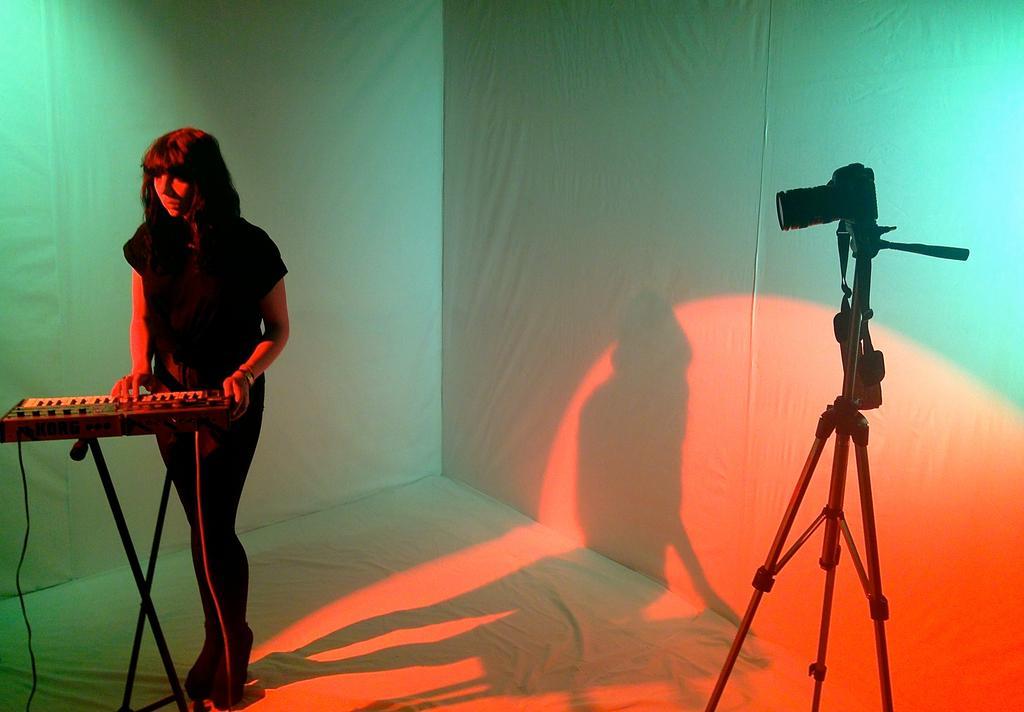Could you give a brief overview of what you see in this image? In this image, at the left side there is a woman, she is standing and she is playing a piano, the piano is kept on the black color stand, at the right side there is a black color stand and there is a black color camera, at the background there are some curtains, on that curtains there is a shadow of a woman. 